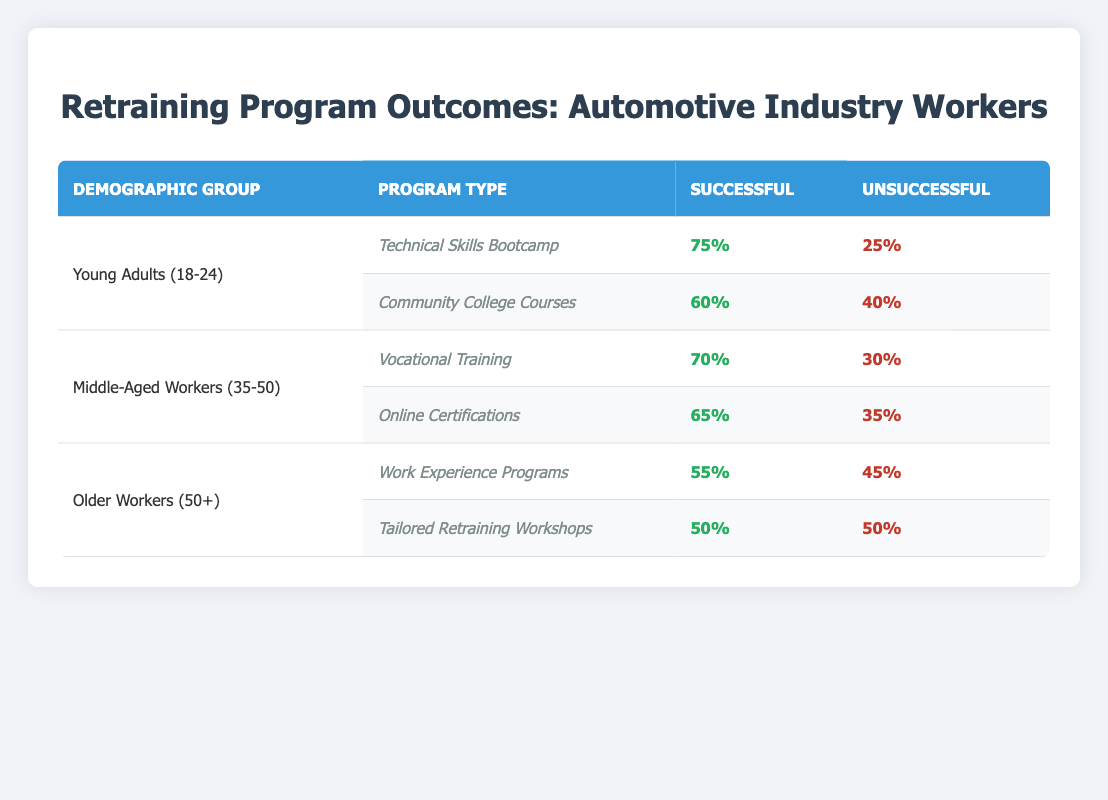What is the success rate of the Technical Skills Bootcamp for Young Adults? The table shows that the Technical Skills Bootcamp has a success rate of 75% for Young Adults (18-24).
Answer: 75% Which demographic group had the highest success rate in their retraining program? By comparing success rates across all demographic groups, Young Adults with the Technical Skills Bootcamp (75%) have the highest success rate.
Answer: Young Adults (18-24) with Technical Skills Bootcamp What is the failure rate of the online certifications for Middle-Aged Workers? The failure rate for the Online Certifications program for Middle-Aged Workers (35-50) is listed as 35% in the table.
Answer: 35% What is the average success rate of retraining programs for Older Workers? The success rates of Older Workers are 55% for Work Experience Programs and 50% for Tailored Retraining Workshops. The average is (55 + 50) / 2 = 52.5%.
Answer: 52.5% Did any program for Older Workers have a success rate higher than 60%? The table indicates that both retraining programs for Older Workers (55% and 50%) have success rates lower than 60%.
Answer: No What is the difference in success rates between the Vocational Training and Online Certifications for Middle-Aged Workers? The success rate for Vocational Training is 70%, and for Online Certifications, it is 65%. The difference is 70 - 65 = 5%.
Answer: 5% What is the total number of unsuccessful outcomes across all programs? To find the total unsuccessful outcomes, we add the unsuccessful outcomes for each program: 25 + 40 + 30 + 35 + 45 + 50 = 225.
Answer: 225 Which program type had the lowest success rate? Upon reviewing the success rates from the table, the Tailored Retraining Workshops for Older Workers had the lowest success rate at 50%.
Answer: Tailored Retraining Workshops What is the combined success rate of the two programs for Young Adults? The success rates for Young Adults are 75% for the Technical Skills Bootcamp and 60% for Community College Courses. The combined success rate can be calculated by considering each program's outcome: (75 + 60) / 2 = 67.5%.
Answer: 67.5% 